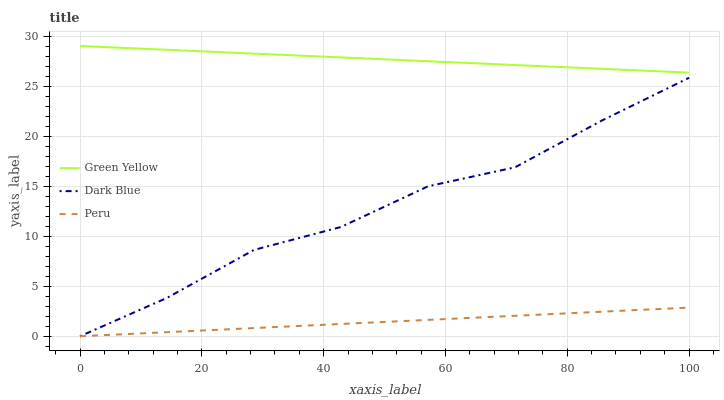Does Peru have the minimum area under the curve?
Answer yes or no. Yes. Does Green Yellow have the maximum area under the curve?
Answer yes or no. Yes. Does Green Yellow have the minimum area under the curve?
Answer yes or no. No. Does Peru have the maximum area under the curve?
Answer yes or no. No. Is Peru the smoothest?
Answer yes or no. Yes. Is Dark Blue the roughest?
Answer yes or no. Yes. Is Green Yellow the smoothest?
Answer yes or no. No. Is Green Yellow the roughest?
Answer yes or no. No. Does Dark Blue have the lowest value?
Answer yes or no. Yes. Does Green Yellow have the lowest value?
Answer yes or no. No. Does Green Yellow have the highest value?
Answer yes or no. Yes. Does Peru have the highest value?
Answer yes or no. No. Is Dark Blue less than Green Yellow?
Answer yes or no. Yes. Is Green Yellow greater than Dark Blue?
Answer yes or no. Yes. Does Peru intersect Dark Blue?
Answer yes or no. Yes. Is Peru less than Dark Blue?
Answer yes or no. No. Is Peru greater than Dark Blue?
Answer yes or no. No. Does Dark Blue intersect Green Yellow?
Answer yes or no. No. 